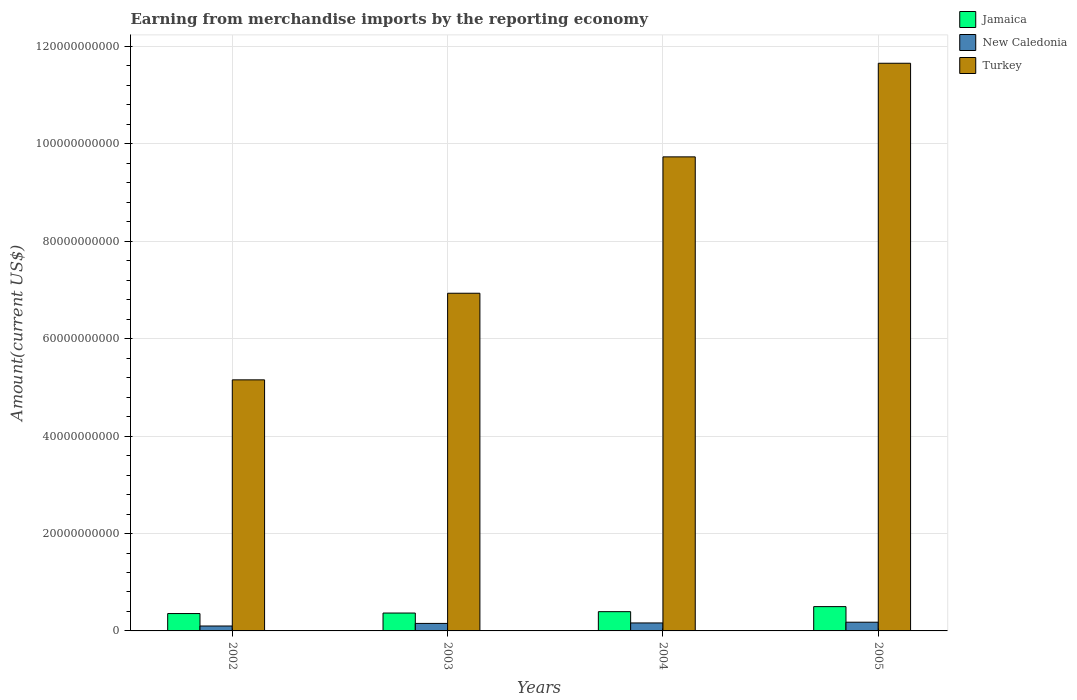How many bars are there on the 2nd tick from the right?
Your answer should be very brief. 3. What is the amount earned from merchandise imports in Turkey in 2002?
Provide a succinct answer. 5.16e+1. Across all years, what is the maximum amount earned from merchandise imports in Turkey?
Offer a very short reply. 1.17e+11. Across all years, what is the minimum amount earned from merchandise imports in Turkey?
Make the answer very short. 5.16e+1. In which year was the amount earned from merchandise imports in Jamaica maximum?
Your answer should be very brief. 2005. In which year was the amount earned from merchandise imports in Turkey minimum?
Keep it short and to the point. 2002. What is the total amount earned from merchandise imports in Turkey in the graph?
Provide a succinct answer. 3.35e+11. What is the difference between the amount earned from merchandise imports in Turkey in 2004 and that in 2005?
Ensure brevity in your answer.  -1.92e+1. What is the difference between the amount earned from merchandise imports in Jamaica in 2005 and the amount earned from merchandise imports in New Caledonia in 2004?
Provide a succinct answer. 3.36e+09. What is the average amount earned from merchandise imports in Jamaica per year?
Provide a short and direct response. 4.05e+09. In the year 2003, what is the difference between the amount earned from merchandise imports in Jamaica and amount earned from merchandise imports in Turkey?
Provide a short and direct response. -6.57e+1. In how many years, is the amount earned from merchandise imports in Turkey greater than 52000000000 US$?
Offer a terse response. 3. What is the ratio of the amount earned from merchandise imports in Turkey in 2003 to that in 2005?
Make the answer very short. 0.59. What is the difference between the highest and the second highest amount earned from merchandise imports in Jamaica?
Your answer should be very brief. 1.04e+09. What is the difference between the highest and the lowest amount earned from merchandise imports in Jamaica?
Your answer should be very brief. 1.43e+09. What does the 2nd bar from the left in 2002 represents?
Provide a short and direct response. New Caledonia. What does the 1st bar from the right in 2005 represents?
Provide a short and direct response. Turkey. How many bars are there?
Provide a short and direct response. 12. Are all the bars in the graph horizontal?
Provide a succinct answer. No. What is the difference between two consecutive major ticks on the Y-axis?
Your answer should be very brief. 2.00e+1. Does the graph contain any zero values?
Your answer should be compact. No. Does the graph contain grids?
Keep it short and to the point. Yes. Where does the legend appear in the graph?
Keep it short and to the point. Top right. What is the title of the graph?
Offer a very short reply. Earning from merchandise imports by the reporting economy. What is the label or title of the X-axis?
Offer a terse response. Years. What is the label or title of the Y-axis?
Give a very brief answer. Amount(current US$). What is the Amount(current US$) of Jamaica in 2002?
Provide a succinct answer. 3.57e+09. What is the Amount(current US$) of New Caledonia in 2002?
Provide a succinct answer. 1.01e+09. What is the Amount(current US$) of Turkey in 2002?
Your response must be concise. 5.16e+1. What is the Amount(current US$) in Jamaica in 2003?
Ensure brevity in your answer.  3.67e+09. What is the Amount(current US$) of New Caledonia in 2003?
Your response must be concise. 1.54e+09. What is the Amount(current US$) in Turkey in 2003?
Offer a terse response. 6.93e+1. What is the Amount(current US$) in Jamaica in 2004?
Provide a succinct answer. 3.95e+09. What is the Amount(current US$) in New Caledonia in 2004?
Make the answer very short. 1.64e+09. What is the Amount(current US$) in Turkey in 2004?
Your answer should be very brief. 9.73e+1. What is the Amount(current US$) in Jamaica in 2005?
Your answer should be very brief. 4.99e+09. What is the Amount(current US$) of New Caledonia in 2005?
Give a very brief answer. 1.79e+09. What is the Amount(current US$) in Turkey in 2005?
Give a very brief answer. 1.17e+11. Across all years, what is the maximum Amount(current US$) in Jamaica?
Make the answer very short. 4.99e+09. Across all years, what is the maximum Amount(current US$) of New Caledonia?
Your response must be concise. 1.79e+09. Across all years, what is the maximum Amount(current US$) in Turkey?
Your answer should be compact. 1.17e+11. Across all years, what is the minimum Amount(current US$) of Jamaica?
Your response must be concise. 3.57e+09. Across all years, what is the minimum Amount(current US$) in New Caledonia?
Offer a terse response. 1.01e+09. Across all years, what is the minimum Amount(current US$) in Turkey?
Make the answer very short. 5.16e+1. What is the total Amount(current US$) of Jamaica in the graph?
Provide a succinct answer. 1.62e+1. What is the total Amount(current US$) of New Caledonia in the graph?
Make the answer very short. 5.97e+09. What is the total Amount(current US$) of Turkey in the graph?
Your answer should be very brief. 3.35e+11. What is the difference between the Amount(current US$) in Jamaica in 2002 and that in 2003?
Keep it short and to the point. -1.06e+08. What is the difference between the Amount(current US$) of New Caledonia in 2002 and that in 2003?
Make the answer very short. -5.34e+08. What is the difference between the Amount(current US$) of Turkey in 2002 and that in 2003?
Keep it short and to the point. -1.78e+1. What is the difference between the Amount(current US$) in Jamaica in 2002 and that in 2004?
Ensure brevity in your answer.  -3.87e+08. What is the difference between the Amount(current US$) of New Caledonia in 2002 and that in 2004?
Offer a very short reply. -6.29e+08. What is the difference between the Amount(current US$) in Turkey in 2002 and that in 2004?
Keep it short and to the point. -4.58e+1. What is the difference between the Amount(current US$) in Jamaica in 2002 and that in 2005?
Provide a short and direct response. -1.43e+09. What is the difference between the Amount(current US$) in New Caledonia in 2002 and that in 2005?
Offer a terse response. -7.82e+08. What is the difference between the Amount(current US$) in Turkey in 2002 and that in 2005?
Ensure brevity in your answer.  -6.50e+1. What is the difference between the Amount(current US$) of Jamaica in 2003 and that in 2004?
Give a very brief answer. -2.81e+08. What is the difference between the Amount(current US$) in New Caledonia in 2003 and that in 2004?
Offer a very short reply. -9.53e+07. What is the difference between the Amount(current US$) in Turkey in 2003 and that in 2004?
Keep it short and to the point. -2.80e+1. What is the difference between the Amount(current US$) of Jamaica in 2003 and that in 2005?
Offer a terse response. -1.32e+09. What is the difference between the Amount(current US$) in New Caledonia in 2003 and that in 2005?
Offer a terse response. -2.48e+08. What is the difference between the Amount(current US$) of Turkey in 2003 and that in 2005?
Keep it short and to the point. -4.72e+1. What is the difference between the Amount(current US$) in Jamaica in 2004 and that in 2005?
Give a very brief answer. -1.04e+09. What is the difference between the Amount(current US$) in New Caledonia in 2004 and that in 2005?
Keep it short and to the point. -1.53e+08. What is the difference between the Amount(current US$) in Turkey in 2004 and that in 2005?
Your response must be concise. -1.92e+1. What is the difference between the Amount(current US$) in Jamaica in 2002 and the Amount(current US$) in New Caledonia in 2003?
Offer a very short reply. 2.03e+09. What is the difference between the Amount(current US$) in Jamaica in 2002 and the Amount(current US$) in Turkey in 2003?
Offer a very short reply. -6.58e+1. What is the difference between the Amount(current US$) in New Caledonia in 2002 and the Amount(current US$) in Turkey in 2003?
Your answer should be very brief. -6.83e+1. What is the difference between the Amount(current US$) in Jamaica in 2002 and the Amount(current US$) in New Caledonia in 2004?
Offer a terse response. 1.93e+09. What is the difference between the Amount(current US$) in Jamaica in 2002 and the Amount(current US$) in Turkey in 2004?
Keep it short and to the point. -9.38e+1. What is the difference between the Amount(current US$) of New Caledonia in 2002 and the Amount(current US$) of Turkey in 2004?
Offer a terse response. -9.63e+1. What is the difference between the Amount(current US$) of Jamaica in 2002 and the Amount(current US$) of New Caledonia in 2005?
Offer a very short reply. 1.78e+09. What is the difference between the Amount(current US$) of Jamaica in 2002 and the Amount(current US$) of Turkey in 2005?
Provide a succinct answer. -1.13e+11. What is the difference between the Amount(current US$) in New Caledonia in 2002 and the Amount(current US$) in Turkey in 2005?
Give a very brief answer. -1.16e+11. What is the difference between the Amount(current US$) in Jamaica in 2003 and the Amount(current US$) in New Caledonia in 2004?
Keep it short and to the point. 2.04e+09. What is the difference between the Amount(current US$) of Jamaica in 2003 and the Amount(current US$) of Turkey in 2004?
Offer a terse response. -9.37e+1. What is the difference between the Amount(current US$) of New Caledonia in 2003 and the Amount(current US$) of Turkey in 2004?
Provide a succinct answer. -9.58e+1. What is the difference between the Amount(current US$) of Jamaica in 2003 and the Amount(current US$) of New Caledonia in 2005?
Your answer should be compact. 1.88e+09. What is the difference between the Amount(current US$) in Jamaica in 2003 and the Amount(current US$) in Turkey in 2005?
Your answer should be compact. -1.13e+11. What is the difference between the Amount(current US$) in New Caledonia in 2003 and the Amount(current US$) in Turkey in 2005?
Your answer should be compact. -1.15e+11. What is the difference between the Amount(current US$) in Jamaica in 2004 and the Amount(current US$) in New Caledonia in 2005?
Offer a very short reply. 2.16e+09. What is the difference between the Amount(current US$) of Jamaica in 2004 and the Amount(current US$) of Turkey in 2005?
Give a very brief answer. -1.13e+11. What is the difference between the Amount(current US$) in New Caledonia in 2004 and the Amount(current US$) in Turkey in 2005?
Ensure brevity in your answer.  -1.15e+11. What is the average Amount(current US$) in Jamaica per year?
Ensure brevity in your answer.  4.05e+09. What is the average Amount(current US$) in New Caledonia per year?
Your answer should be compact. 1.49e+09. What is the average Amount(current US$) of Turkey per year?
Your answer should be compact. 8.37e+1. In the year 2002, what is the difference between the Amount(current US$) of Jamaica and Amount(current US$) of New Caledonia?
Give a very brief answer. 2.56e+09. In the year 2002, what is the difference between the Amount(current US$) of Jamaica and Amount(current US$) of Turkey?
Your response must be concise. -4.80e+1. In the year 2002, what is the difference between the Amount(current US$) in New Caledonia and Amount(current US$) in Turkey?
Keep it short and to the point. -5.05e+1. In the year 2003, what is the difference between the Amount(current US$) in Jamaica and Amount(current US$) in New Caledonia?
Your answer should be very brief. 2.13e+09. In the year 2003, what is the difference between the Amount(current US$) of Jamaica and Amount(current US$) of Turkey?
Your answer should be compact. -6.57e+1. In the year 2003, what is the difference between the Amount(current US$) in New Caledonia and Amount(current US$) in Turkey?
Your response must be concise. -6.78e+1. In the year 2004, what is the difference between the Amount(current US$) of Jamaica and Amount(current US$) of New Caledonia?
Keep it short and to the point. 2.32e+09. In the year 2004, what is the difference between the Amount(current US$) in Jamaica and Amount(current US$) in Turkey?
Give a very brief answer. -9.34e+1. In the year 2004, what is the difference between the Amount(current US$) in New Caledonia and Amount(current US$) in Turkey?
Provide a succinct answer. -9.57e+1. In the year 2005, what is the difference between the Amount(current US$) of Jamaica and Amount(current US$) of New Caledonia?
Provide a short and direct response. 3.20e+09. In the year 2005, what is the difference between the Amount(current US$) in Jamaica and Amount(current US$) in Turkey?
Your response must be concise. -1.12e+11. In the year 2005, what is the difference between the Amount(current US$) of New Caledonia and Amount(current US$) of Turkey?
Give a very brief answer. -1.15e+11. What is the ratio of the Amount(current US$) in Jamaica in 2002 to that in 2003?
Provide a succinct answer. 0.97. What is the ratio of the Amount(current US$) in New Caledonia in 2002 to that in 2003?
Your answer should be compact. 0.65. What is the ratio of the Amount(current US$) in Turkey in 2002 to that in 2003?
Your answer should be very brief. 0.74. What is the ratio of the Amount(current US$) in Jamaica in 2002 to that in 2004?
Provide a short and direct response. 0.9. What is the ratio of the Amount(current US$) in New Caledonia in 2002 to that in 2004?
Offer a terse response. 0.62. What is the ratio of the Amount(current US$) of Turkey in 2002 to that in 2004?
Offer a terse response. 0.53. What is the ratio of the Amount(current US$) of Jamaica in 2002 to that in 2005?
Make the answer very short. 0.71. What is the ratio of the Amount(current US$) in New Caledonia in 2002 to that in 2005?
Keep it short and to the point. 0.56. What is the ratio of the Amount(current US$) in Turkey in 2002 to that in 2005?
Offer a very short reply. 0.44. What is the ratio of the Amount(current US$) in Jamaica in 2003 to that in 2004?
Offer a terse response. 0.93. What is the ratio of the Amount(current US$) in New Caledonia in 2003 to that in 2004?
Provide a succinct answer. 0.94. What is the ratio of the Amount(current US$) in Turkey in 2003 to that in 2004?
Ensure brevity in your answer.  0.71. What is the ratio of the Amount(current US$) in Jamaica in 2003 to that in 2005?
Offer a terse response. 0.74. What is the ratio of the Amount(current US$) of New Caledonia in 2003 to that in 2005?
Ensure brevity in your answer.  0.86. What is the ratio of the Amount(current US$) of Turkey in 2003 to that in 2005?
Offer a very short reply. 0.59. What is the ratio of the Amount(current US$) in Jamaica in 2004 to that in 2005?
Your answer should be compact. 0.79. What is the ratio of the Amount(current US$) in New Caledonia in 2004 to that in 2005?
Make the answer very short. 0.91. What is the ratio of the Amount(current US$) of Turkey in 2004 to that in 2005?
Offer a terse response. 0.84. What is the difference between the highest and the second highest Amount(current US$) of Jamaica?
Make the answer very short. 1.04e+09. What is the difference between the highest and the second highest Amount(current US$) in New Caledonia?
Keep it short and to the point. 1.53e+08. What is the difference between the highest and the second highest Amount(current US$) of Turkey?
Offer a very short reply. 1.92e+1. What is the difference between the highest and the lowest Amount(current US$) in Jamaica?
Provide a succinct answer. 1.43e+09. What is the difference between the highest and the lowest Amount(current US$) of New Caledonia?
Your response must be concise. 7.82e+08. What is the difference between the highest and the lowest Amount(current US$) of Turkey?
Make the answer very short. 6.50e+1. 